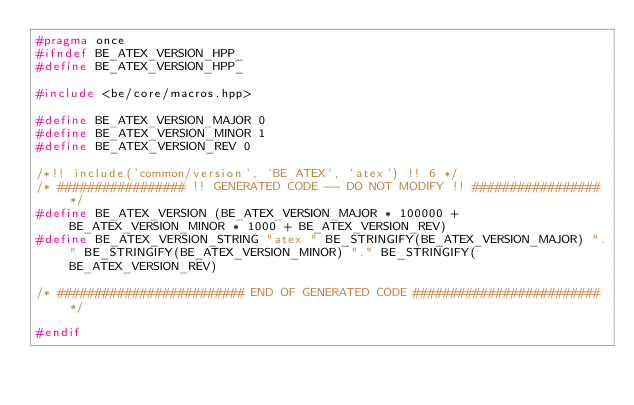<code> <loc_0><loc_0><loc_500><loc_500><_C++_>#pragma once
#ifndef BE_ATEX_VERSION_HPP_
#define BE_ATEX_VERSION_HPP_

#include <be/core/macros.hpp>

#define BE_ATEX_VERSION_MAJOR 0
#define BE_ATEX_VERSION_MINOR 1
#define BE_ATEX_VERSION_REV 0

/*!! include('common/version', 'BE_ATEX', 'atex') !! 6 */
/* ################# !! GENERATED CODE -- DO NOT MODIFY !! ################# */
#define BE_ATEX_VERSION (BE_ATEX_VERSION_MAJOR * 100000 + BE_ATEX_VERSION_MINOR * 1000 + BE_ATEX_VERSION_REV)
#define BE_ATEX_VERSION_STRING "atex " BE_STRINGIFY(BE_ATEX_VERSION_MAJOR) "." BE_STRINGIFY(BE_ATEX_VERSION_MINOR) "." BE_STRINGIFY(BE_ATEX_VERSION_REV)

/* ######################### END OF GENERATED CODE ######################### */

#endif
</code> 